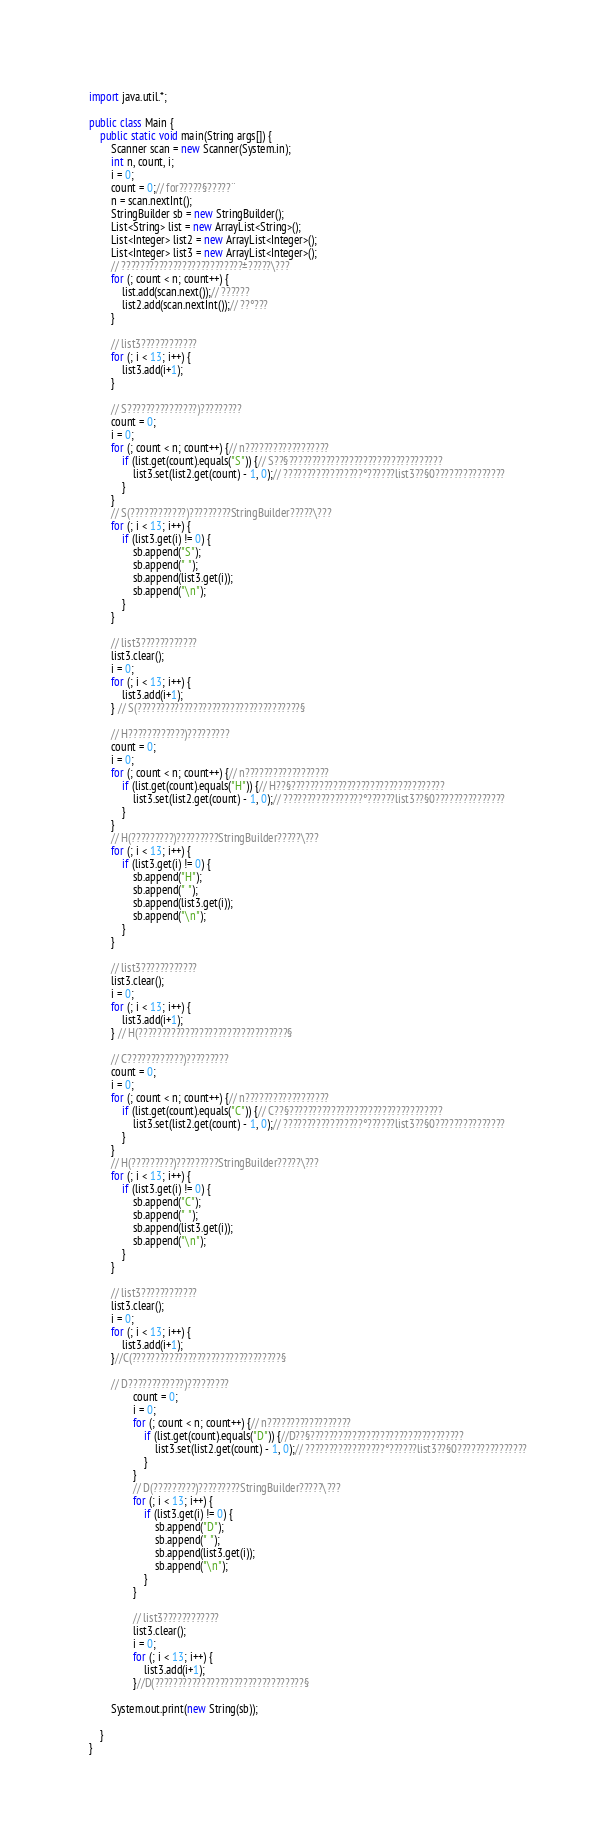Convert code to text. <code><loc_0><loc_0><loc_500><loc_500><_Java_>

import java.util.*;

public class Main {
	public static void main(String args[]) {
		Scanner scan = new Scanner(System.in);
		int n, count, i;
		i = 0;
		count = 0;// for?????§?????¨
		n = scan.nextInt();
		StringBuilder sb = new StringBuilder();
		List<String> list = new ArrayList<String>();
		List<Integer> list2 = new ArrayList<Integer>();
		List<Integer> list3 = new ArrayList<Integer>();
		// ??????????????????????????±?????\???
		for (; count < n; count++) {
			list.add(scan.next());// ??????
			list2.add(scan.nextInt());// ??°???
		}

		// list3????????????
		for (; i < 13; i++) {
			list3.add(i+1);
		}

		// S???????????????)?????????
		count = 0;
		i = 0;
		for (; count < n; count++) {// n??????????????????
			if (list.get(count).equals("S")) {// S??§?????????????????????????????????
				list3.set(list2.get(count) - 1, 0);// ?????????????????°??????list3??§0???????????????
			}
		}
		// S(????????????)?????????StringBuilder?????\???
		for (; i < 13; i++) {
			if (list3.get(i) != 0) {
				sb.append("S");
				sb.append(" ");
				sb.append(list3.get(i));
				sb.append("\n");
			}
		}

		// list3????????????
		list3.clear();
		i = 0;
		for (; i < 13; i++) {
			list3.add(i+1);
		} // S(???????????????????????????????????§

		// H????????????)?????????
		count = 0;
		i = 0;
		for (; count < n; count++) {// n??????????????????
			if (list.get(count).equals("H")) {// H??§?????????????????????????????????
				list3.set(list2.get(count) - 1, 0);// ?????????????????°??????list3??§0???????????????
			}
		}
		// H(?????????)?????????StringBuilder?????\???
		for (; i < 13; i++) {
			if (list3.get(i) != 0) {
				sb.append("H");
				sb.append(" ");
				sb.append(list3.get(i));
				sb.append("\n");
			}
		}

		// list3????????????
		list3.clear();
		i = 0;
		for (; i < 13; i++) {
			list3.add(i+1);
		} // H(????????????????????????????????§
		
		// C????????????)?????????
		count = 0;
		i = 0;
		for (; count < n; count++) {// n??????????????????
			if (list.get(count).equals("C")) {// C??§?????????????????????????????????
				list3.set(list2.get(count) - 1, 0);// ?????????????????°??????list3??§0???????????????
			}
		}
		// H(?????????)?????????StringBuilder?????\???
		for (; i < 13; i++) {
			if (list3.get(i) != 0) {
				sb.append("C");
				sb.append(" ");
				sb.append(list3.get(i));
				sb.append("\n");
			}
		}

		// list3????????????
		list3.clear();
		i = 0;
		for (; i < 13; i++) {
			list3.add(i+1);
		}//C(????????????????????????????????§
		
		// D????????????)?????????
				count = 0;
				i = 0;
				for (; count < n; count++) {// n??????????????????
					if (list.get(count).equals("D")) {//D??§?????????????????????????????????
						list3.set(list2.get(count) - 1, 0);// ?????????????????°??????list3??§0???????????????
					}
				}
				// D(?????????)?????????StringBuilder?????\???
				for (; i < 13; i++) {
					if (list3.get(i) != 0) {
						sb.append("D");
						sb.append(" ");
						sb.append(list3.get(i));
						sb.append("\n");
					}
				}

				// list3????????????
				list3.clear();
				i = 0;
				for (; i < 13; i++) {
					list3.add(i+1);
				}//D(????????????????????????????????§

		System.out.print(new String(sb));

	}
}</code> 